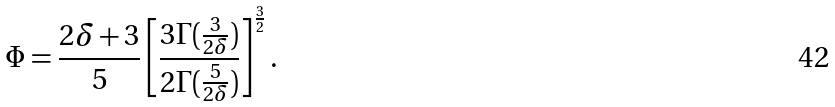Convert formula to latex. <formula><loc_0><loc_0><loc_500><loc_500>\Phi = \frac { 2 \delta + 3 } { 5 } \left [ \frac { 3 \Gamma ( \frac { 3 } { 2 \delta } ) } { 2 \Gamma ( \frac { 5 } { 2 \delta } ) } \right ] ^ { \frac { 3 } { 2 } } .</formula> 